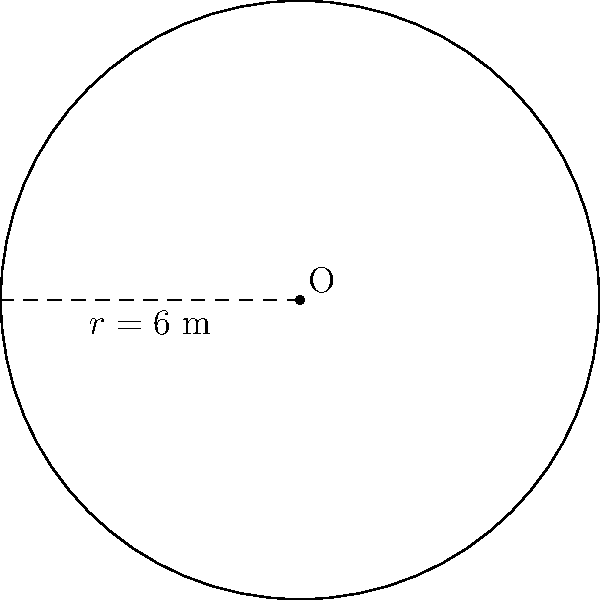On your travels, you encounter a traditional circular dwelling with a radius of 6 meters. Calculate the total floor area of this dwelling in square meters. Use $\pi = 3.14$ for your calculations. To calculate the area of a circular dwelling, we can use the formula for the area of a circle:

$$A = \pi r^2$$

Where:
$A$ = area of the circle
$\pi$ = pi (given as 3.14)
$r$ = radius of the circle

Given:
$r = 6$ meters
$\pi = 3.14$

Step 1: Substitute the values into the formula:
$$A = 3.14 \times 6^2$$

Step 2: Calculate the square of the radius:
$$A = 3.14 \times 36$$

Step 3: Multiply:
$$A = 113.04$$

Therefore, the total floor area of the circular dwelling is 113.04 square meters.
Answer: 113.04 m² 